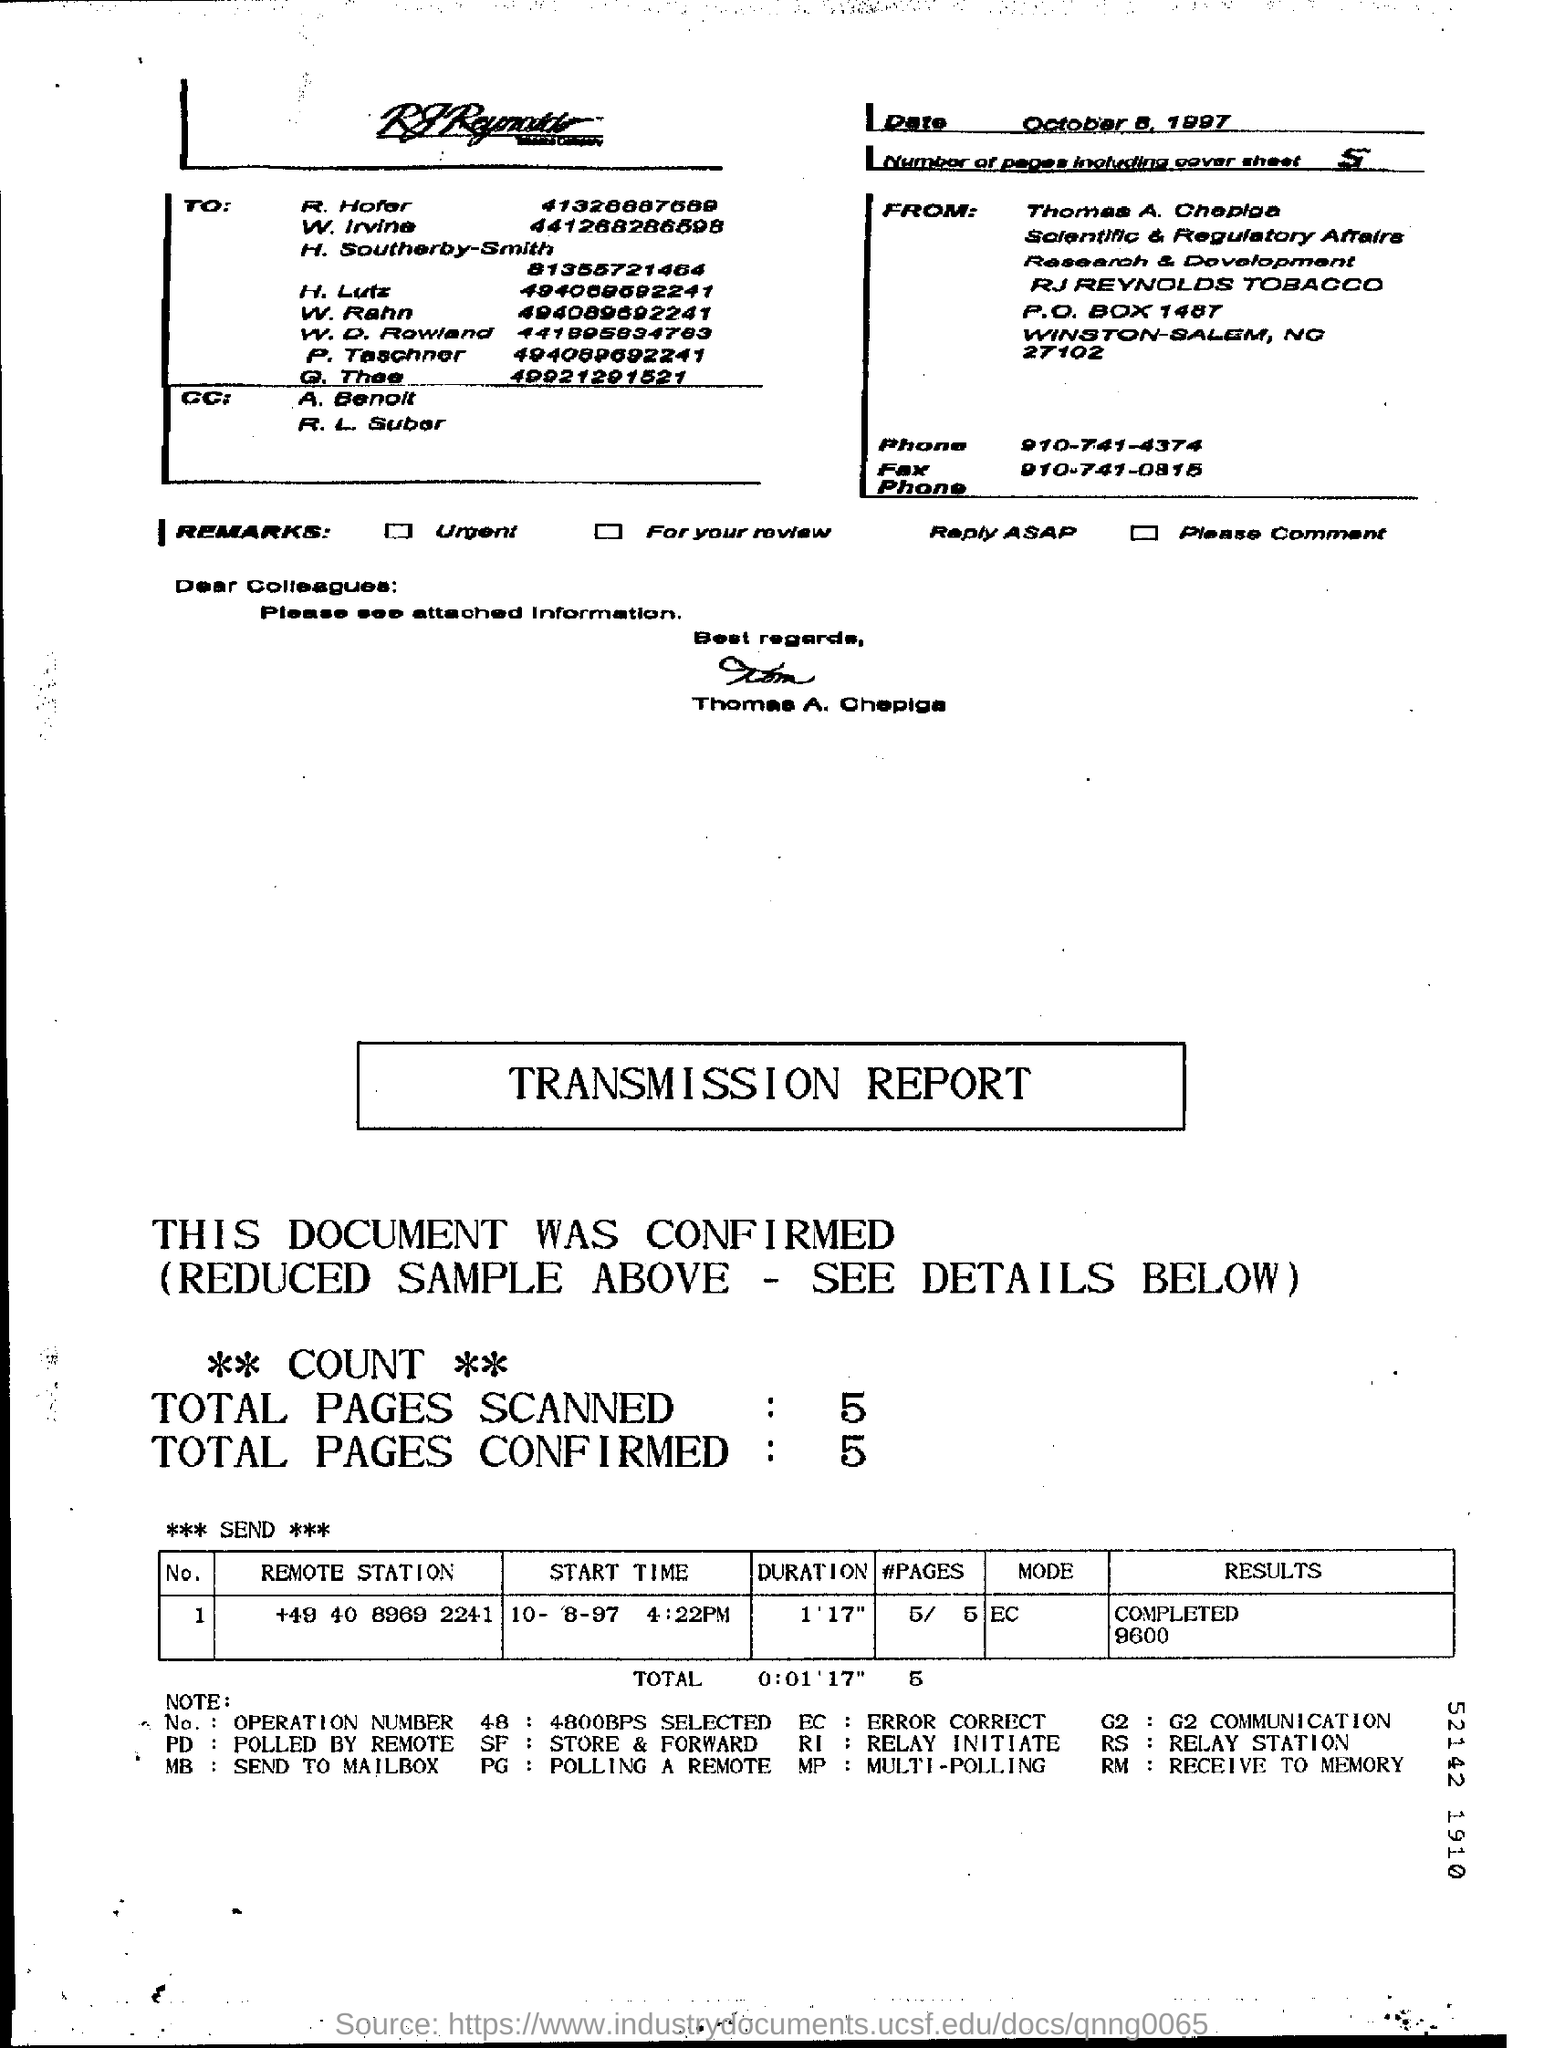Indicate a few pertinent items in this graphic. The total number of pages, including the cover sheet, is five. The total number of confirmed pages in the transmission report is 5. The full form of the abbreviation EC is ERROR CORRECTING. The full form of RS is "Relay Station. The transmission report shows a total of 5 scanned pages. 